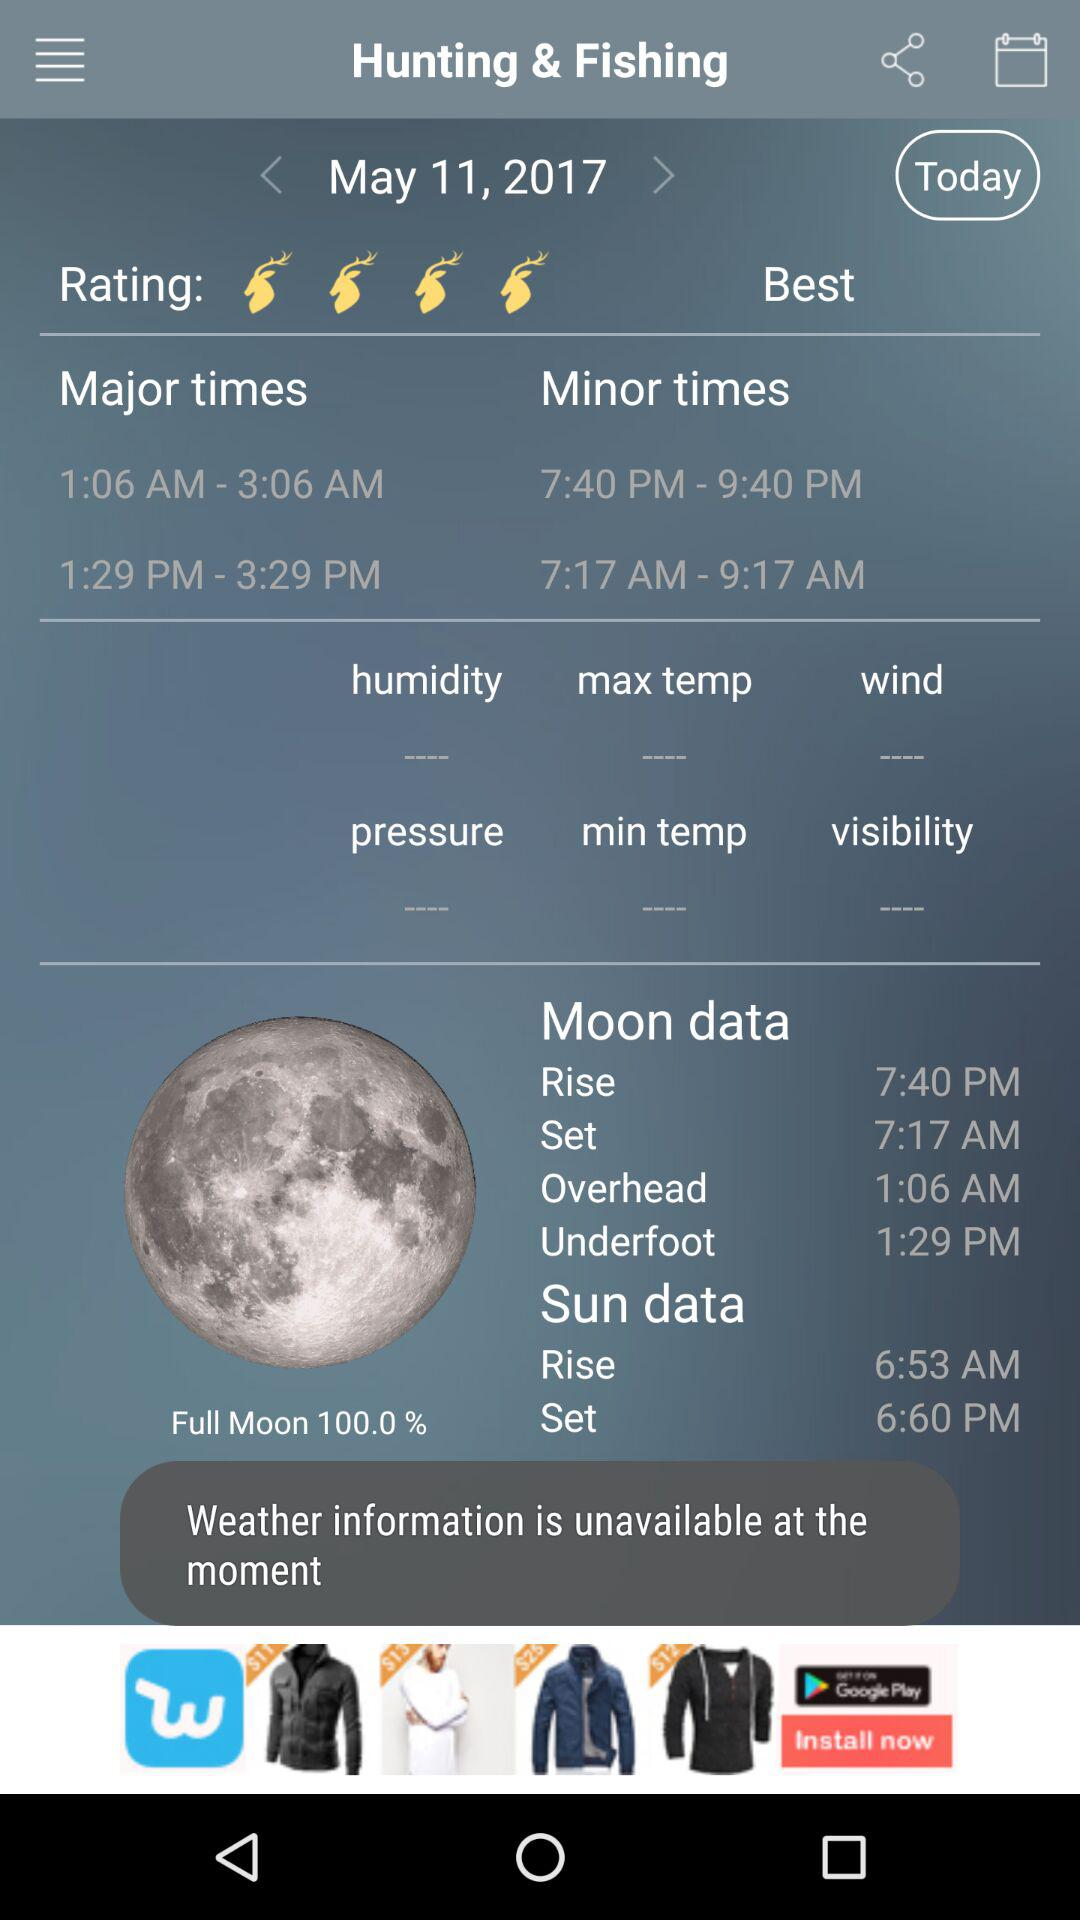At what time does the sun set? The sun sets at 6:60 p.m. 